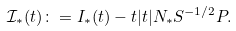<formula> <loc_0><loc_0><loc_500><loc_500>{ \mathcal { I } } _ { * } ( t ) \colon = I _ { * } ( t ) - t | t | N _ { * } S ^ { - 1 / 2 } P .</formula> 